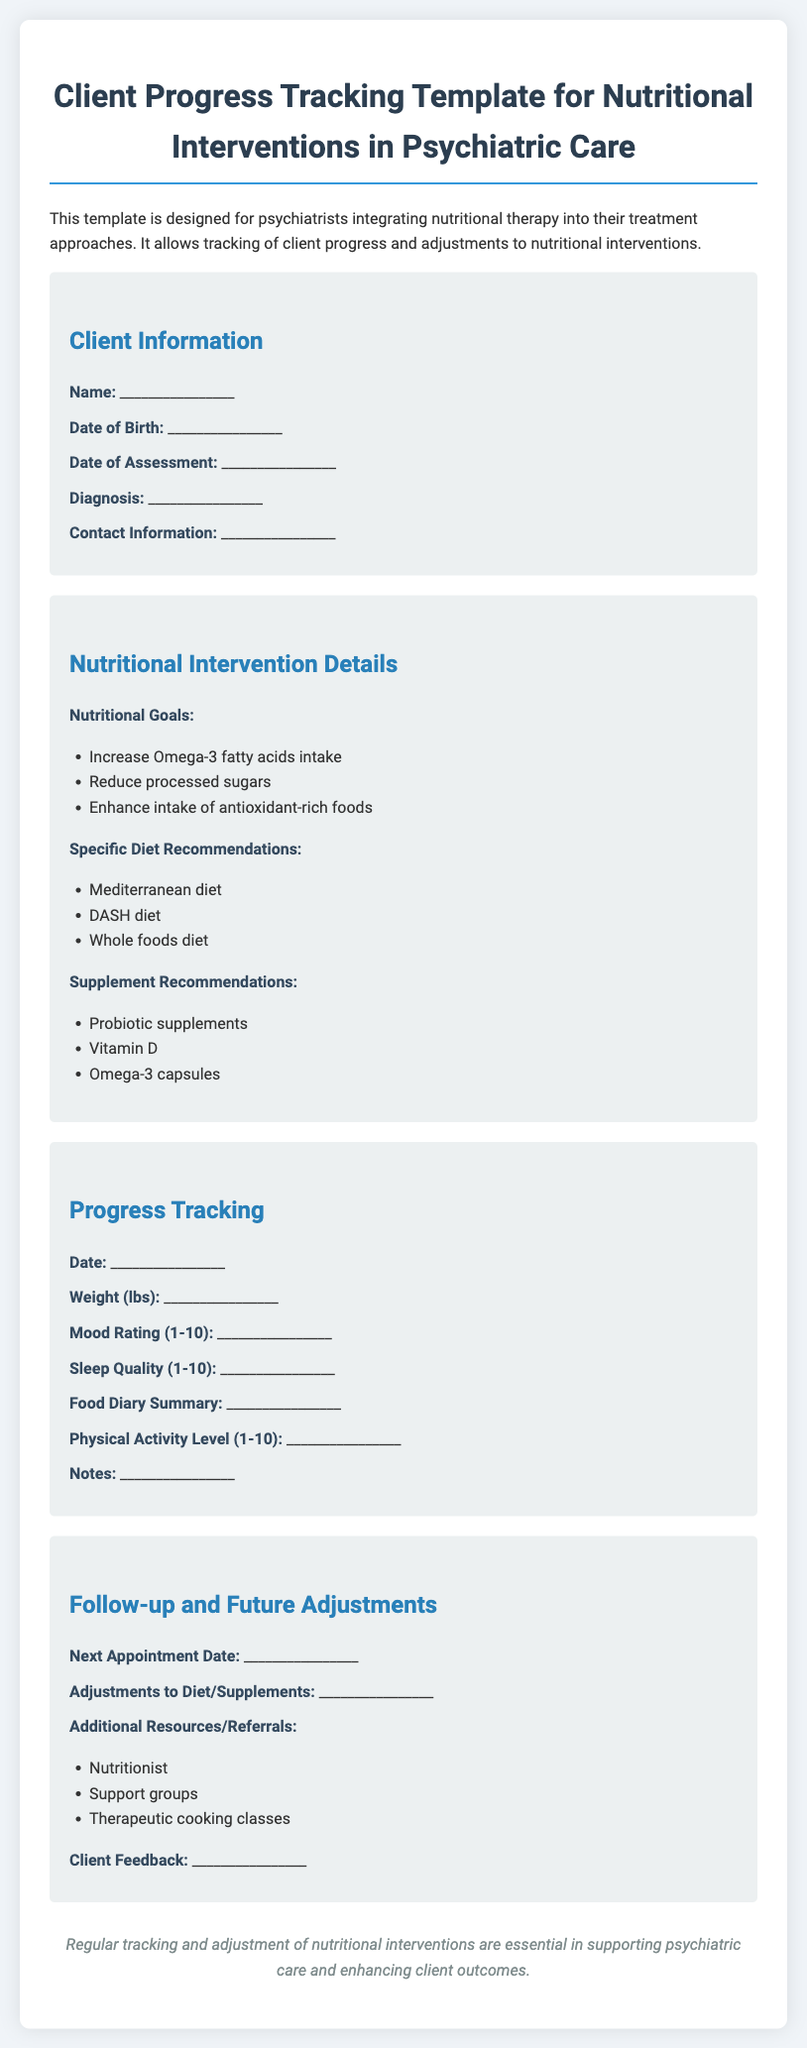What is the title of the document? The title is specified at the beginning of the document, presented in large font.
Answer: Client Progress Tracking Template for Nutritional Interventions in Psychiatric Care What is the date of assessment? The date of assessment is a specific field that the user is required to fill out in the Client Information section.
Answer: ________________ What are the nutritional goals listed? The nutritional goals can be found in the Nutritional Intervention Details section in bullet points.
Answer: Increase Omega-3 fatty acids intake, Reduce processed sugars, Enhance intake of antioxidant-rich foods What is the mood rating scale? The mood rating scale is provided in the Progress Tracking section, indicating the range for client feedback.
Answer: 1-10 What is the next appointment date? This field is part of the Follow-up and Future Adjustments section and needs to be filled out during client tracking.
Answer: ________________ What type of diet is recommended? The recommended diet types are listed in the Nutritional Intervention Details section as a part of specific recommendations.
Answer: Mediterranean diet, DASH diet, Whole foods diet What is included in the follow-up resources? The Follow-up and Future Adjustments section includes a list of additional resources or referrals for the client.
Answer: Nutritionist, Support groups, Therapeutic cooking classes How should progress be tracked? The required information to track progress includes several specific fields outlined in the Progress Tracking section.
Answer: Weight, Mood Rating, Sleep Quality, Food Diary Summary, Physical Activity Level, Notes What type of supplements are recommended? The recommended supplements can be found in the Nutritional Intervention Details section and are listed in bullet form.
Answer: Probiotic supplements, Vitamin D, Omega-3 capsules 